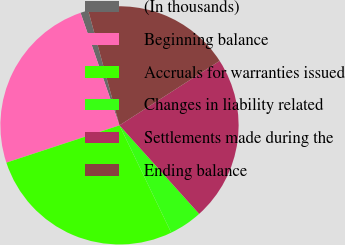Convert chart. <chart><loc_0><loc_0><loc_500><loc_500><pie_chart><fcel>(In thousands)<fcel>Beginning balance<fcel>Accruals for warranties issued<fcel>Changes in liability related<fcel>Settlements made during the<fcel>Ending balance<nl><fcel>1.07%<fcel>24.76%<fcel>27.08%<fcel>4.51%<fcel>22.44%<fcel>20.12%<nl></chart> 